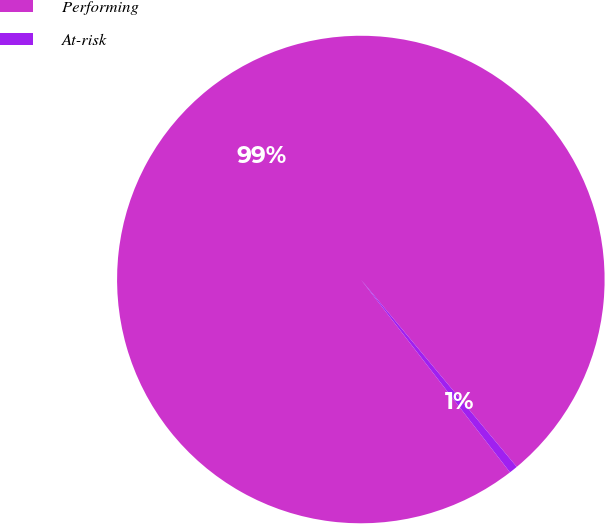Convert chart. <chart><loc_0><loc_0><loc_500><loc_500><pie_chart><fcel>Performing<fcel>At-risk<nl><fcel>99.43%<fcel>0.57%<nl></chart> 